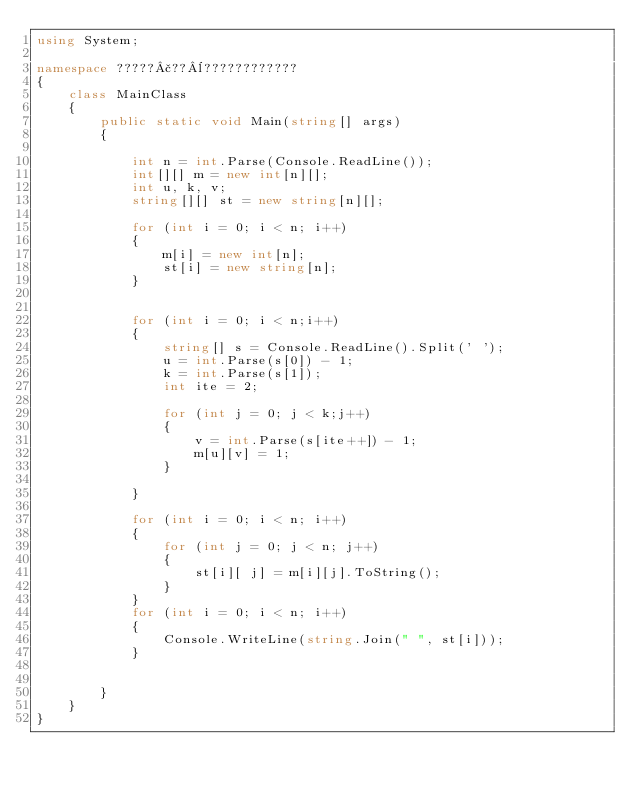<code> <loc_0><loc_0><loc_500><loc_500><_C#_>using System;

namespace ?????£??¨????????????
{
    class MainClass
    {
        public static void Main(string[] args)
        {

            int n = int.Parse(Console.ReadLine());
            int[][] m = new int[n][];
            int u, k, v;
            string[][] st = new string[n][];

            for (int i = 0; i < n; i++)
            {
                m[i] = new int[n];
                st[i] = new string[n];
            }


            for (int i = 0; i < n;i++)
            {
                string[] s = Console.ReadLine().Split(' ');
                u = int.Parse(s[0]) - 1;
                k = int.Parse(s[1]);
                int ite = 2;

                for (int j = 0; j < k;j++)
                {
                    v = int.Parse(s[ite++]) - 1;
                    m[u][v] = 1;
                }

            }

            for (int i = 0; i < n; i++)
            {
                for (int j = 0; j < n; j++)
                {
                    st[i][ j] = m[i][j].ToString();
                }
            }
            for (int i = 0; i < n; i++)
            {
                Console.WriteLine(string.Join(" ", st[i]));
            }


        }
    }
}</code> 